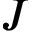<formula> <loc_0><loc_0><loc_500><loc_500>J</formula> 